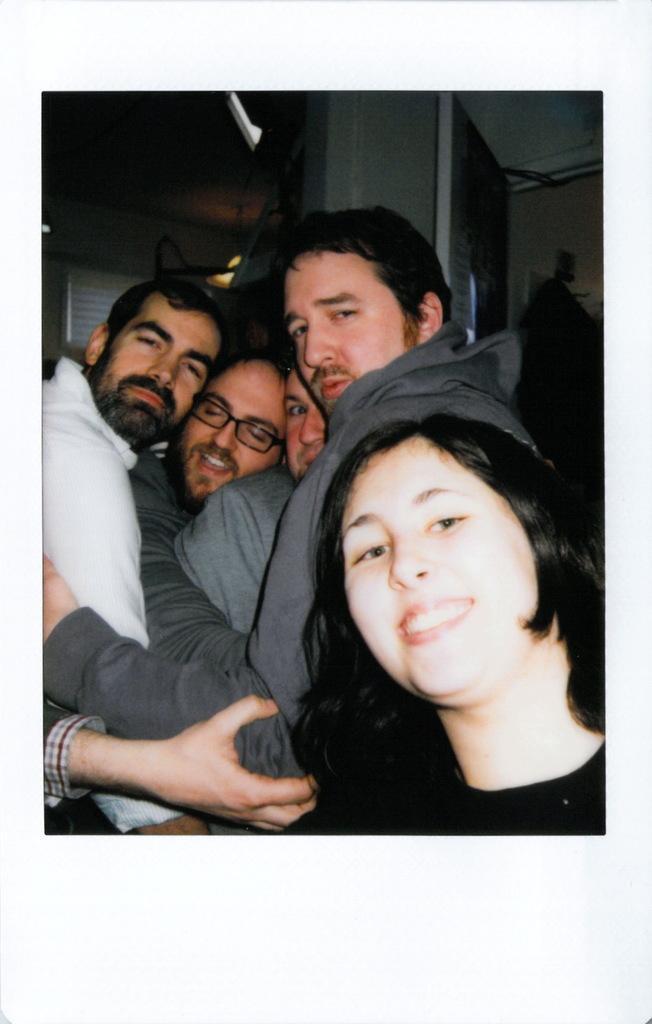Can you describe this image briefly? In this image we can see a group of people standing. One person is wearing spectacles. One woman is wearing black dress. In the background, we can see some lights and a window. 